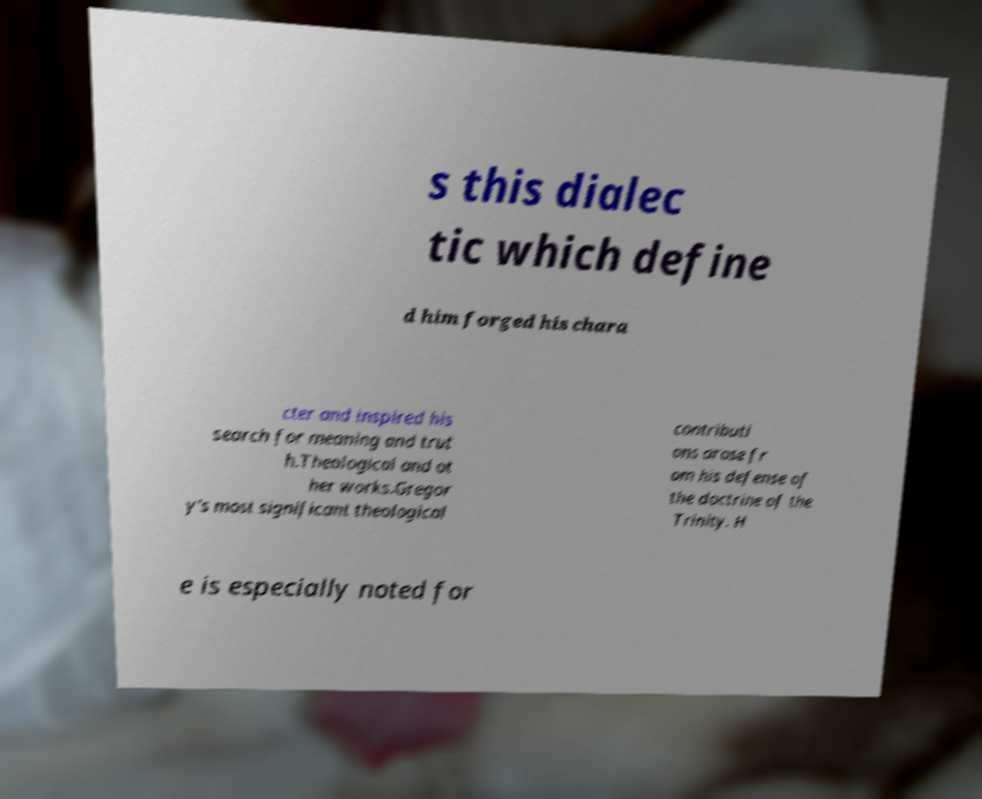Can you read and provide the text displayed in the image?This photo seems to have some interesting text. Can you extract and type it out for me? s this dialec tic which define d him forged his chara cter and inspired his search for meaning and trut h.Theological and ot her works.Gregor y's most significant theological contributi ons arose fr om his defense of the doctrine of the Trinity. H e is especially noted for 